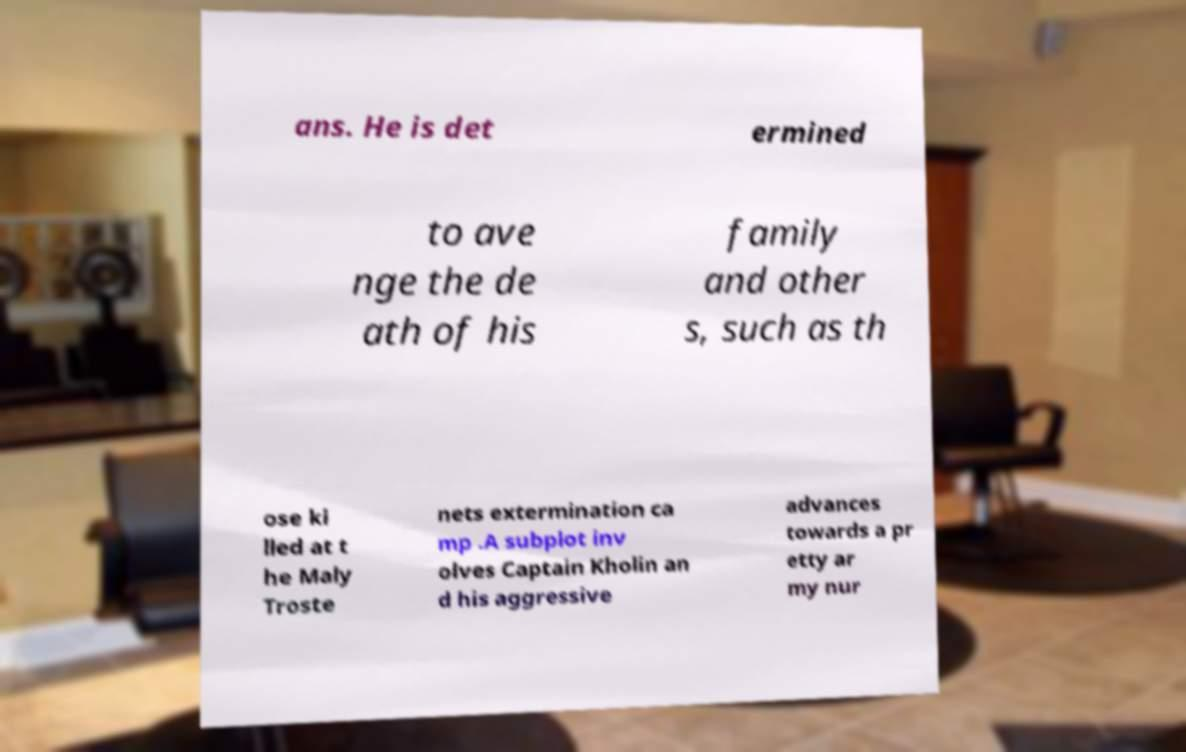Could you assist in decoding the text presented in this image and type it out clearly? ans. He is det ermined to ave nge the de ath of his family and other s, such as th ose ki lled at t he Maly Troste nets extermination ca mp .A subplot inv olves Captain Kholin an d his aggressive advances towards a pr etty ar my nur 